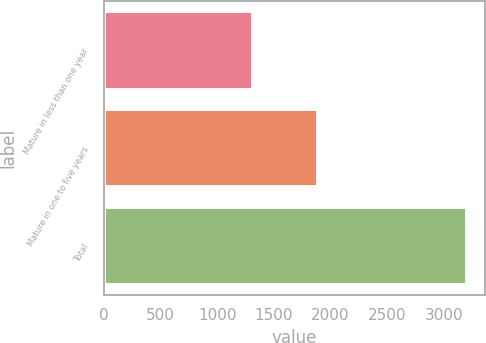Convert chart to OTSL. <chart><loc_0><loc_0><loc_500><loc_500><bar_chart><fcel>Mature in less than one year<fcel>Mature in one to five years<fcel>Total<nl><fcel>1317.9<fcel>1885.9<fcel>3203.8<nl></chart> 